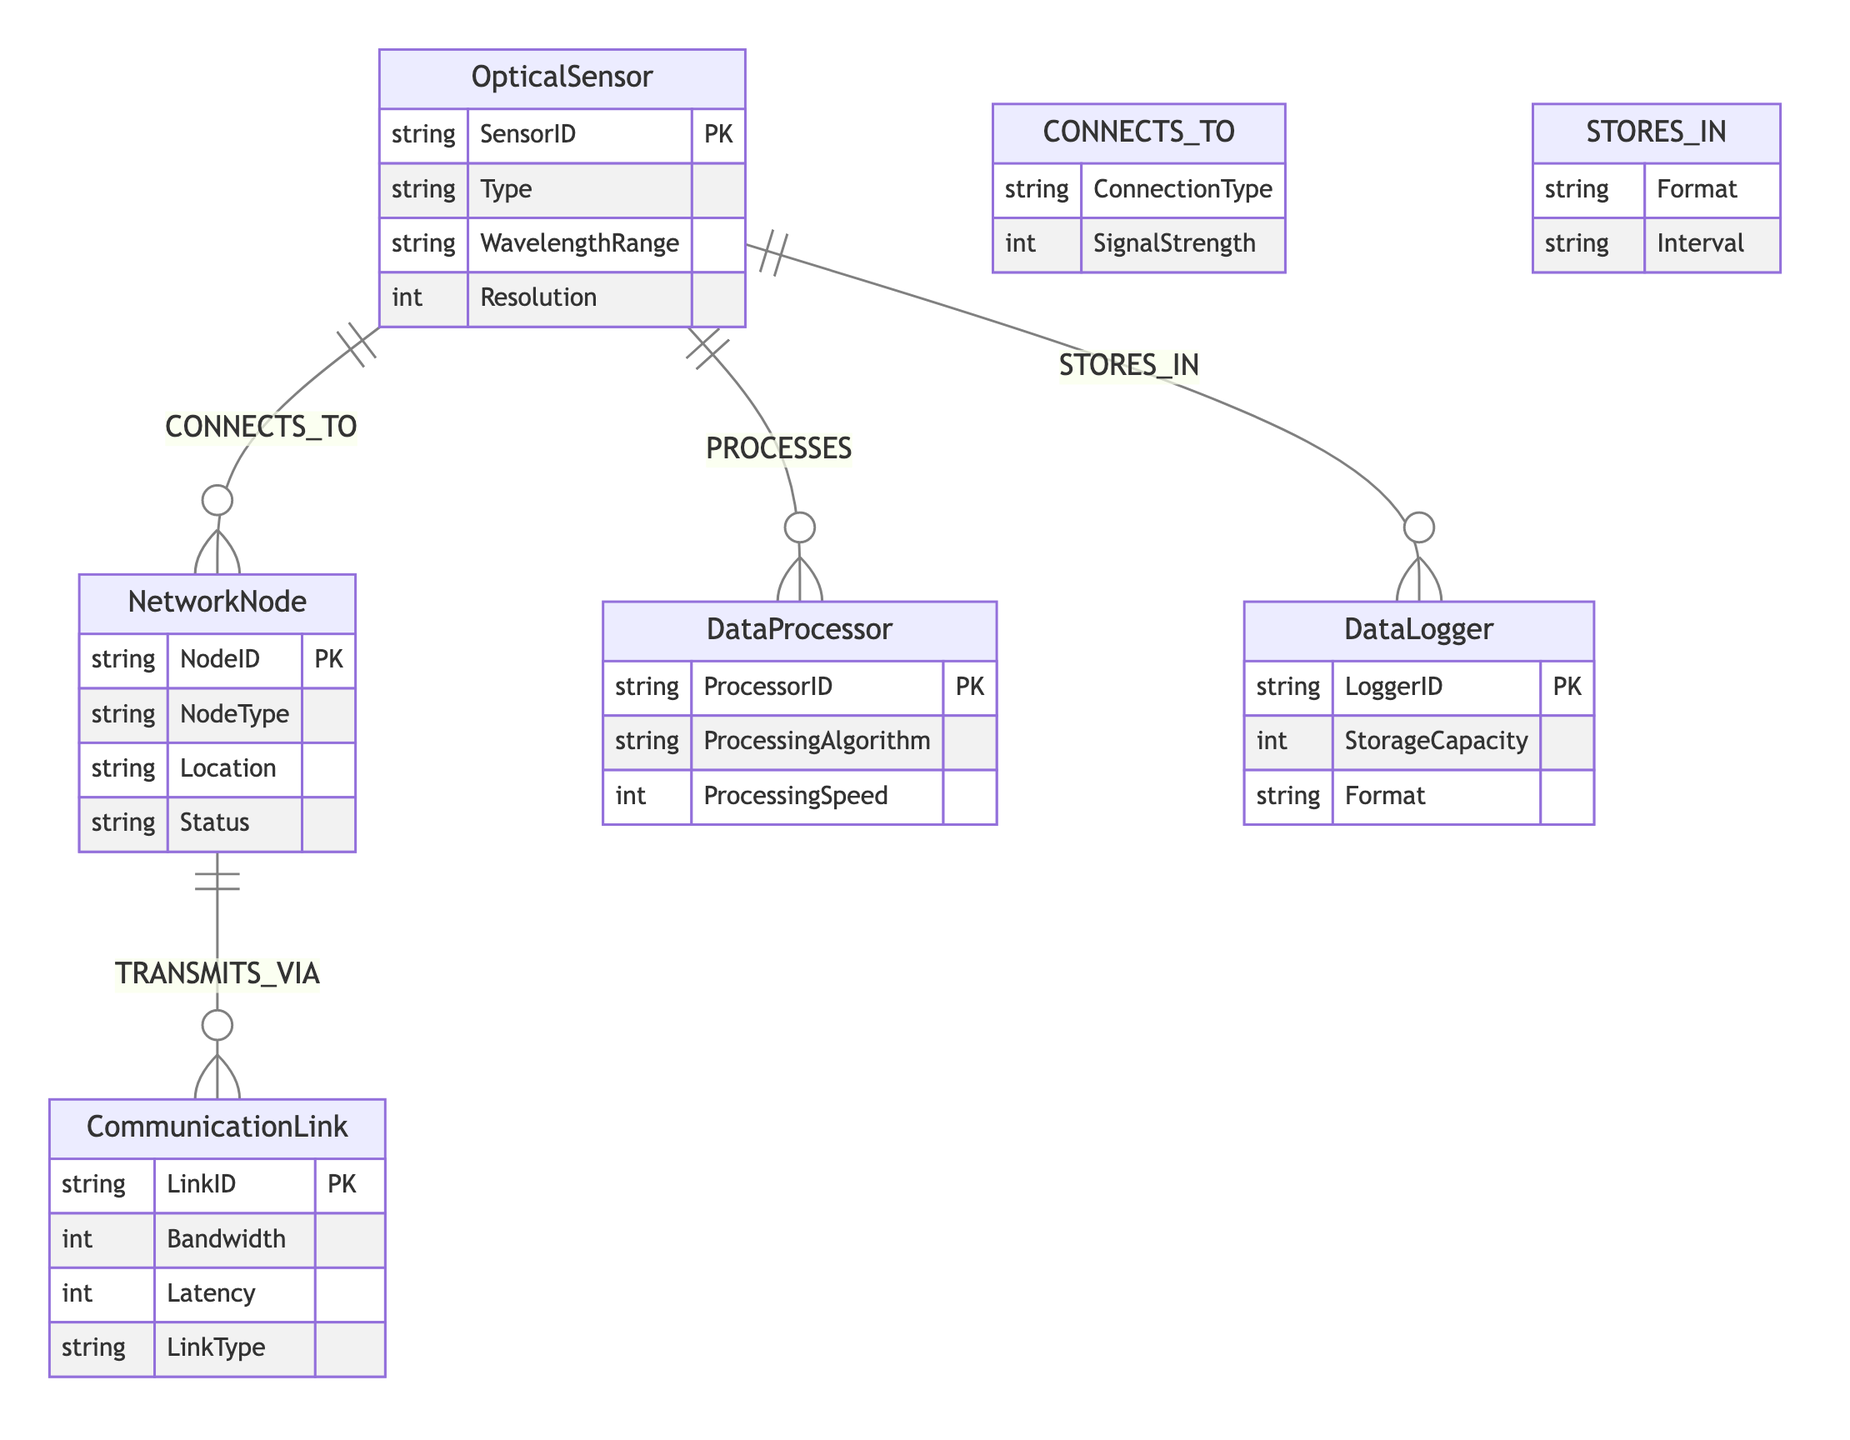What is the primary entity that connects to NetworkNode? The diagram indicates a direct relationship where OpticalSensor connects to NetworkNode through the CONNECTS_TO relationship. Therefore, OpticalSensor is the primary entity associated with NetworkNode.
Answer: OpticalSensor How many attributes does the DataProcessor entity have? By examining the DataProcessor entity in the diagram, we see it lists three attributes: ProcessorID, ProcessingAlgorithm, and ProcessingSpeed. Therefore, there are three attributes.
Answer: 3 What type of relationship is represented between OpticalSensor and DataLogger? Referring to the diagram, we see a relationship labeled STORES_IN connecting OpticalSensor and DataLogger, indicating how data from OpticalSensor is stored in DataLogger.
Answer: STORES_IN Which entity represents the processing component in the diagram? The diagram clearly identifies the DataProcessor entity as the component responsible for processing data from OpticalSensor, making it the processing entity within the system.
Answer: DataProcessor What attribute measures the bandwidth in the CommunicationLink entity? The CommunicationLink entity includes an attribute labeled Bandwidth, which specifically measures the bandwidth of that communication link, helping to understand communication capacities.
Answer: Bandwidth Identify the node type of a NetworkNode. The diagram states that the NetworkNode entity has an attribute named NodeType, explicitly characterizing the type assigned to that network node.
Answer: NodeType How many relationships are defined in this diagram? Upon reviewing the relationships listed in the diagram, we note four distinct relationships: CONNECTS_TO, PROCESSES, TRANSMITS_VIA, and STORES_IN, resulting in a total of four relationships defined.
Answer: 4 What is the connection type attribute in the CONNECTS_TO relationship? The CONNECTS_TO relationship features a connection type attribute that defines how OpticalSensor connects to NetworkNode, highlighting the specific connection characteristics involved.
Answer: ConnectionType What is the status attribute in the NetworkNode entity? Within the NetworkNode entity, there is an attribute named Status, which describes the operational status of that network node, providing insight into its condition or activity.
Answer: Status 